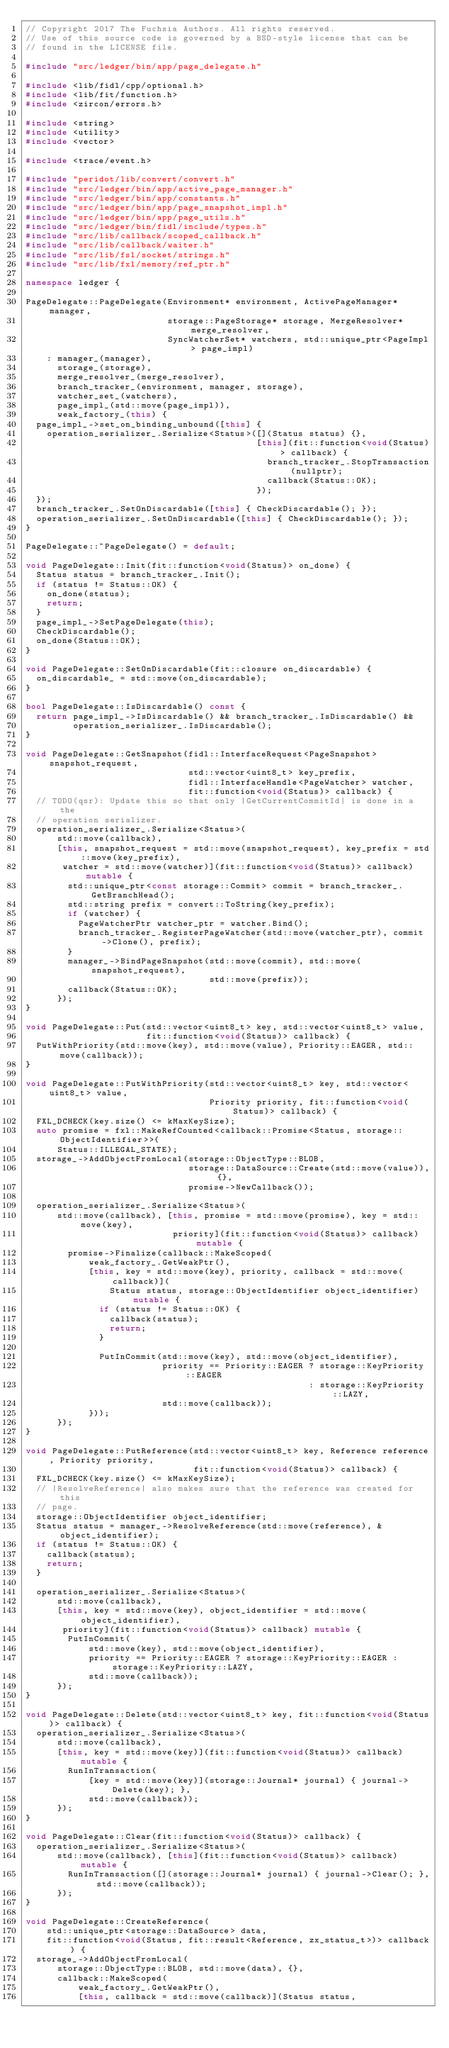<code> <loc_0><loc_0><loc_500><loc_500><_C++_>// Copyright 2017 The Fuchsia Authors. All rights reserved.
// Use of this source code is governed by a BSD-style license that can be
// found in the LICENSE file.

#include "src/ledger/bin/app/page_delegate.h"

#include <lib/fidl/cpp/optional.h>
#include <lib/fit/function.h>
#include <zircon/errors.h>

#include <string>
#include <utility>
#include <vector>

#include <trace/event.h>

#include "peridot/lib/convert/convert.h"
#include "src/ledger/bin/app/active_page_manager.h"
#include "src/ledger/bin/app/constants.h"
#include "src/ledger/bin/app/page_snapshot_impl.h"
#include "src/ledger/bin/app/page_utils.h"
#include "src/ledger/bin/fidl/include/types.h"
#include "src/lib/callback/scoped_callback.h"
#include "src/lib/callback/waiter.h"
#include "src/lib/fsl/socket/strings.h"
#include "src/lib/fxl/memory/ref_ptr.h"

namespace ledger {

PageDelegate::PageDelegate(Environment* environment, ActivePageManager* manager,
                           storage::PageStorage* storage, MergeResolver* merge_resolver,
                           SyncWatcherSet* watchers, std::unique_ptr<PageImpl> page_impl)
    : manager_(manager),
      storage_(storage),
      merge_resolver_(merge_resolver),
      branch_tracker_(environment, manager, storage),
      watcher_set_(watchers),
      page_impl_(std::move(page_impl)),
      weak_factory_(this) {
  page_impl_->set_on_binding_unbound([this] {
    operation_serializer_.Serialize<Status>([](Status status) {},
                                            [this](fit::function<void(Status)> callback) {
                                              branch_tracker_.StopTransaction(nullptr);
                                              callback(Status::OK);
                                            });
  });
  branch_tracker_.SetOnDiscardable([this] { CheckDiscardable(); });
  operation_serializer_.SetOnDiscardable([this] { CheckDiscardable(); });
}

PageDelegate::~PageDelegate() = default;

void PageDelegate::Init(fit::function<void(Status)> on_done) {
  Status status = branch_tracker_.Init();
  if (status != Status::OK) {
    on_done(status);
    return;
  }
  page_impl_->SetPageDelegate(this);
  CheckDiscardable();
  on_done(Status::OK);
}

void PageDelegate::SetOnDiscardable(fit::closure on_discardable) {
  on_discardable_ = std::move(on_discardable);
}

bool PageDelegate::IsDiscardable() const {
  return page_impl_->IsDiscardable() && branch_tracker_.IsDiscardable() &&
         operation_serializer_.IsDiscardable();
}

void PageDelegate::GetSnapshot(fidl::InterfaceRequest<PageSnapshot> snapshot_request,
                               std::vector<uint8_t> key_prefix,
                               fidl::InterfaceHandle<PageWatcher> watcher,
                               fit::function<void(Status)> callback) {
  // TODO(qsr): Update this so that only |GetCurrentCommitId| is done in a the
  // operation serializer.
  operation_serializer_.Serialize<Status>(
      std::move(callback),
      [this, snapshot_request = std::move(snapshot_request), key_prefix = std::move(key_prefix),
       watcher = std::move(watcher)](fit::function<void(Status)> callback) mutable {
        std::unique_ptr<const storage::Commit> commit = branch_tracker_.GetBranchHead();
        std::string prefix = convert::ToString(key_prefix);
        if (watcher) {
          PageWatcherPtr watcher_ptr = watcher.Bind();
          branch_tracker_.RegisterPageWatcher(std::move(watcher_ptr), commit->Clone(), prefix);
        }
        manager_->BindPageSnapshot(std::move(commit), std::move(snapshot_request),
                                   std::move(prefix));
        callback(Status::OK);
      });
}

void PageDelegate::Put(std::vector<uint8_t> key, std::vector<uint8_t> value,
                       fit::function<void(Status)> callback) {
  PutWithPriority(std::move(key), std::move(value), Priority::EAGER, std::move(callback));
}

void PageDelegate::PutWithPriority(std::vector<uint8_t> key, std::vector<uint8_t> value,
                                   Priority priority, fit::function<void(Status)> callback) {
  FXL_DCHECK(key.size() <= kMaxKeySize);
  auto promise = fxl::MakeRefCounted<callback::Promise<Status, storage::ObjectIdentifier>>(
      Status::ILLEGAL_STATE);
  storage_->AddObjectFromLocal(storage::ObjectType::BLOB,
                               storage::DataSource::Create(std::move(value)), {},
                               promise->NewCallback());

  operation_serializer_.Serialize<Status>(
      std::move(callback), [this, promise = std::move(promise), key = std::move(key),
                            priority](fit::function<void(Status)> callback) mutable {
        promise->Finalize(callback::MakeScoped(
            weak_factory_.GetWeakPtr(),
            [this, key = std::move(key), priority, callback = std::move(callback)](
                Status status, storage::ObjectIdentifier object_identifier) mutable {
              if (status != Status::OK) {
                callback(status);
                return;
              }

              PutInCommit(std::move(key), std::move(object_identifier),
                          priority == Priority::EAGER ? storage::KeyPriority::EAGER
                                                      : storage::KeyPriority::LAZY,
                          std::move(callback));
            }));
      });
}

void PageDelegate::PutReference(std::vector<uint8_t> key, Reference reference, Priority priority,
                                fit::function<void(Status)> callback) {
  FXL_DCHECK(key.size() <= kMaxKeySize);
  // |ResolveReference| also makes sure that the reference was created for this
  // page.
  storage::ObjectIdentifier object_identifier;
  Status status = manager_->ResolveReference(std::move(reference), &object_identifier);
  if (status != Status::OK) {
    callback(status);
    return;
  }

  operation_serializer_.Serialize<Status>(
      std::move(callback),
      [this, key = std::move(key), object_identifier = std::move(object_identifier),
       priority](fit::function<void(Status)> callback) mutable {
        PutInCommit(
            std::move(key), std::move(object_identifier),
            priority == Priority::EAGER ? storage::KeyPriority::EAGER : storage::KeyPriority::LAZY,
            std::move(callback));
      });
}

void PageDelegate::Delete(std::vector<uint8_t> key, fit::function<void(Status)> callback) {
  operation_serializer_.Serialize<Status>(
      std::move(callback),
      [this, key = std::move(key)](fit::function<void(Status)> callback) mutable {
        RunInTransaction(
            [key = std::move(key)](storage::Journal* journal) { journal->Delete(key); },
            std::move(callback));
      });
}

void PageDelegate::Clear(fit::function<void(Status)> callback) {
  operation_serializer_.Serialize<Status>(
      std::move(callback), [this](fit::function<void(Status)> callback) mutable {
        RunInTransaction([](storage::Journal* journal) { journal->Clear(); }, std::move(callback));
      });
}

void PageDelegate::CreateReference(
    std::unique_ptr<storage::DataSource> data,
    fit::function<void(Status, fit::result<Reference, zx_status_t>)> callback) {
  storage_->AddObjectFromLocal(
      storage::ObjectType::BLOB, std::move(data), {},
      callback::MakeScoped(
          weak_factory_.GetWeakPtr(),
          [this, callback = std::move(callback)](Status status,</code> 